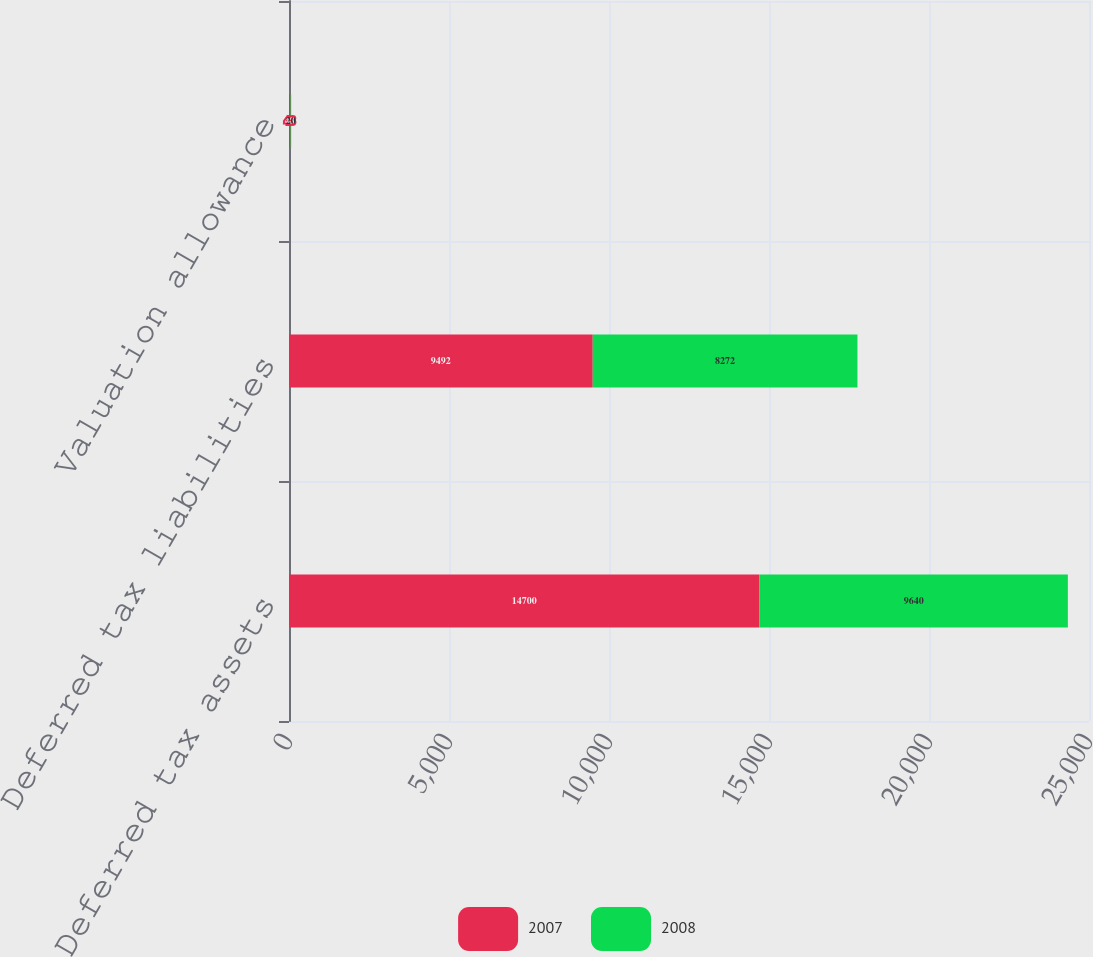<chart> <loc_0><loc_0><loc_500><loc_500><stacked_bar_chart><ecel><fcel>Deferred tax assets<fcel>Deferred tax liabilities<fcel>Valuation allowance<nl><fcel>2007<fcel>14700<fcel>9492<fcel>48<nl><fcel>2008<fcel>9640<fcel>8272<fcel>20<nl></chart> 